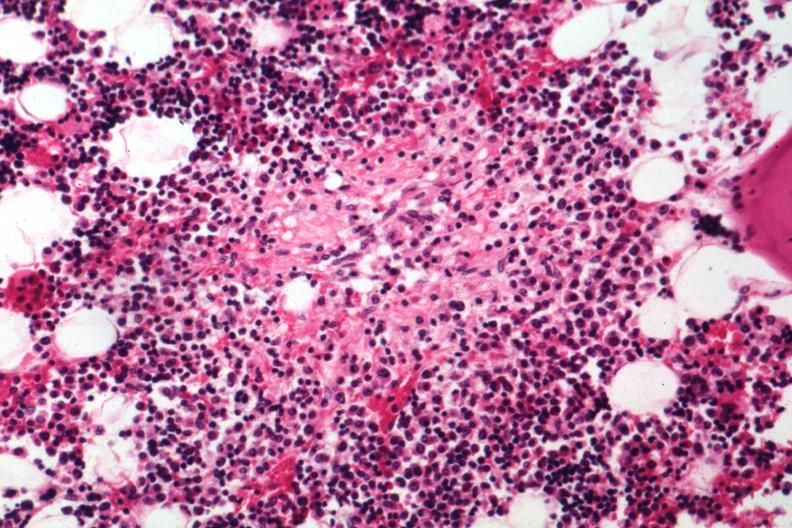what is present?
Answer the question using a single word or phrase. Bone marrow 